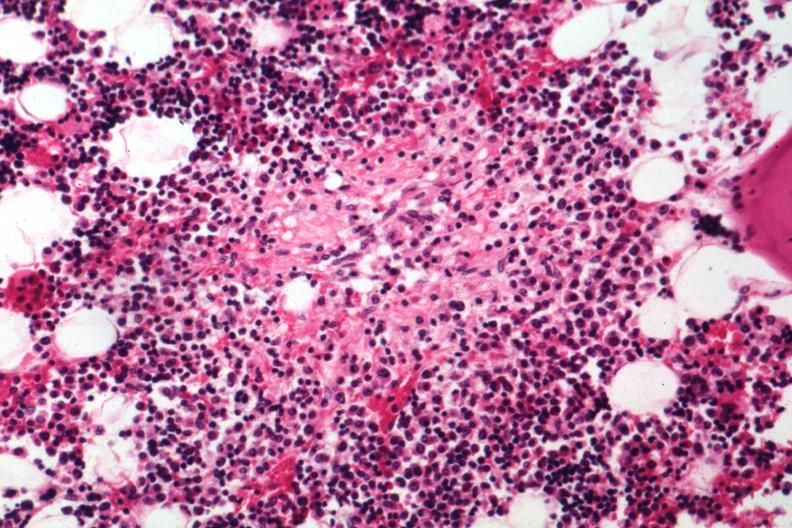what is present?
Answer the question using a single word or phrase. Bone marrow 